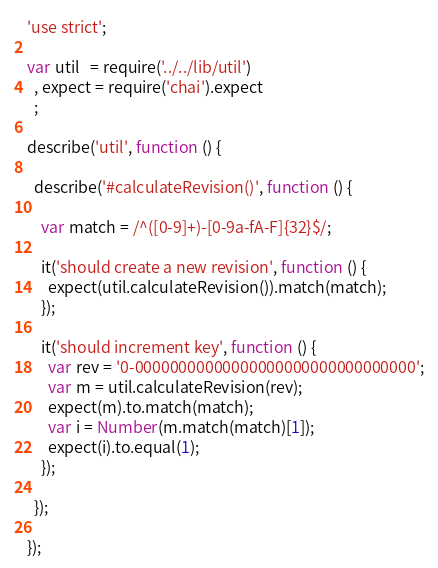<code> <loc_0><loc_0><loc_500><loc_500><_JavaScript_>'use strict';

var util   = require('../../lib/util')
  , expect = require('chai').expect
  ;

describe('util', function () {

  describe('#calculateRevision()', function () {

    var match = /^([0-9]+)-[0-9a-fA-F]{32}$/;

    it('should create a new revision', function () {
      expect(util.calculateRevision()).match(match);
    });

    it('should increment key', function () {
      var rev = '0-00000000000000000000000000000000';
      var m = util.calculateRevision(rev);
      expect(m).to.match(match);
      var i = Number(m.match(match)[1]);
      expect(i).to.equal(1);
    });

  });

});
</code> 